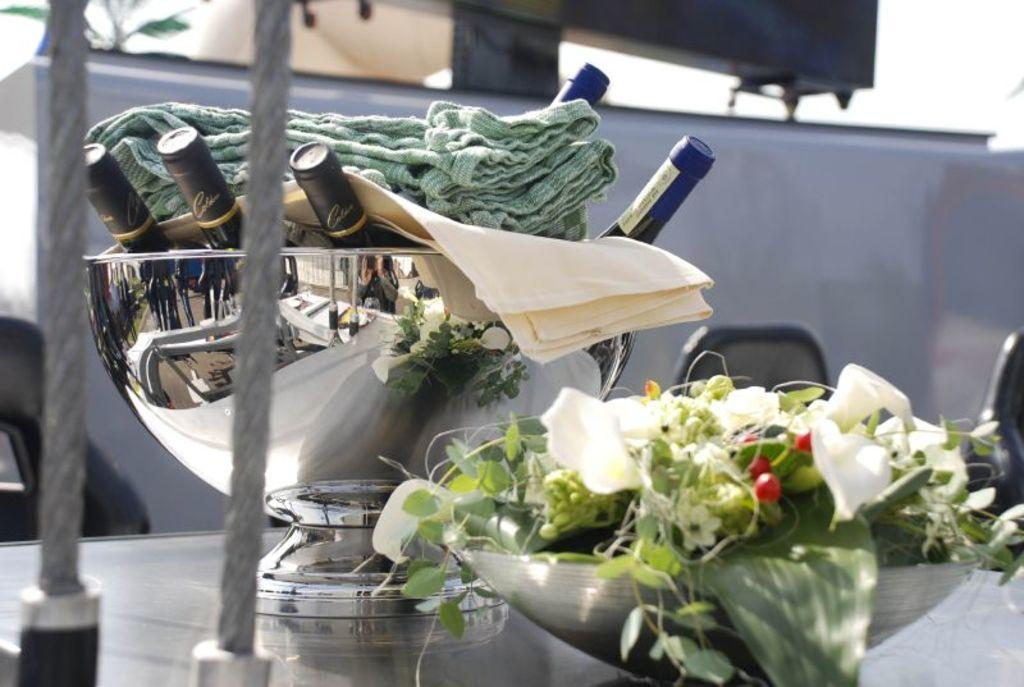How many bowls are on the table in the image? There are two bowls on the table in the image. What is inside the bowls? The bowls contain bottles, clothes, flowers, and plants. Can you describe the wall visible behind the bowls? There is a wall visible behind the bowls, but no specific details are provided about its appearance. What type of arithmetic problem is being solved on the wall in the image? There is no arithmetic problem visible on the wall in the image. Are there any police officers present in the image? There is no mention of police officers in the provided facts, so we cannot determine their presence in the image. 